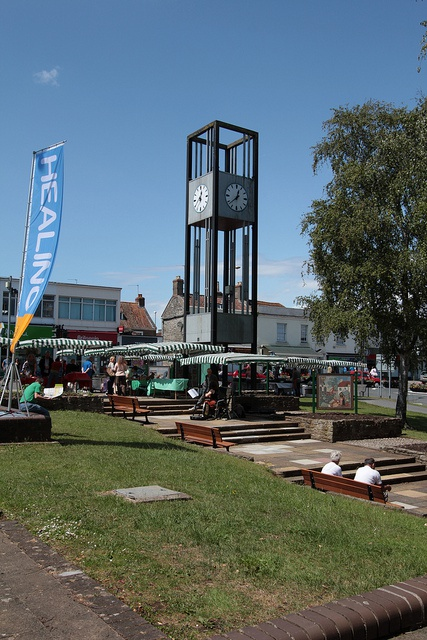Describe the objects in this image and their specific colors. I can see bench in gray, maroon, black, and brown tones, couch in gray and black tones, bench in gray, maroon, black, and brown tones, people in gray, black, turquoise, and teal tones, and bench in gray, black, maroon, and brown tones in this image. 